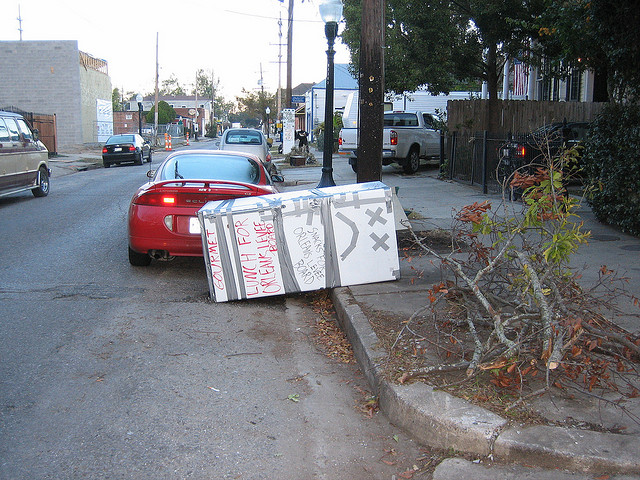Please extract the text content from this image. Gourmet LUNCH FOR POPGO LEVEE BOARD SNACKS ORLEANS 